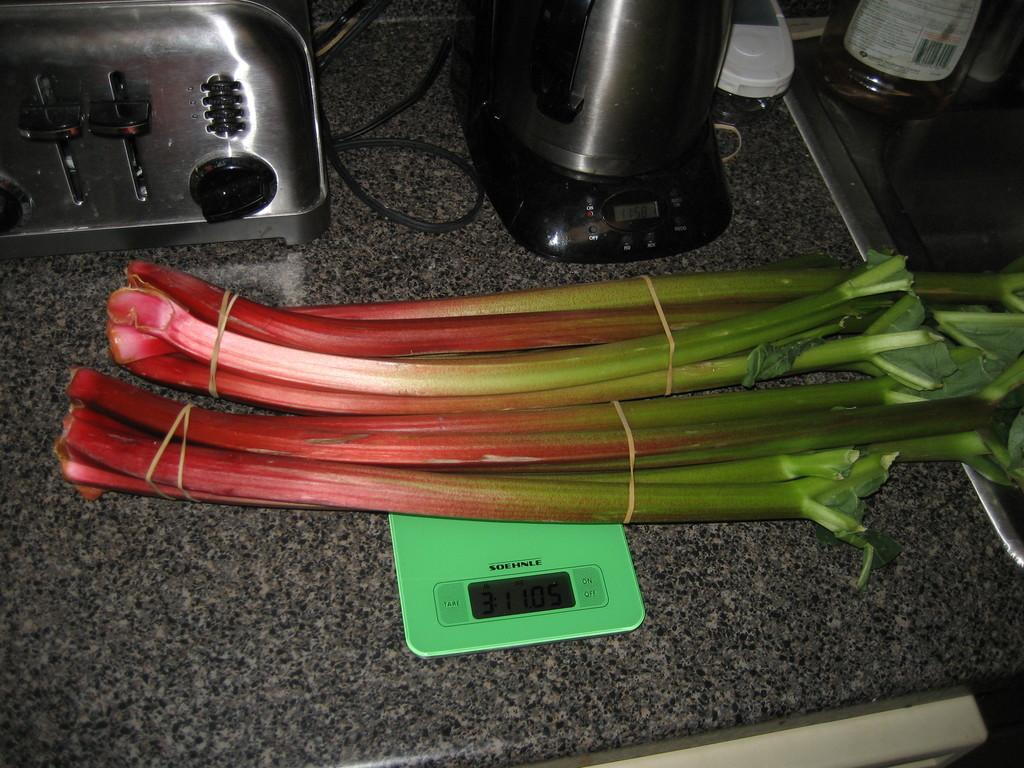What is the main object in the image? There is a weighing machine in the image. What is placed on the weighing machine? A food item is present on the weighing machine. What type of device can be seen in the image? There is an electronic device in the image. What is another object visible in the image? There is a bottle in the image. What is the material of the surface in the image? There is a marble surface in the image. How many boats are visible in the image? There are no boats present in the image. What type of vegetable is being weighed on the weighing machine? The food item on the weighing machine is not specified as a vegetable, and celery is not mentioned in the image. 